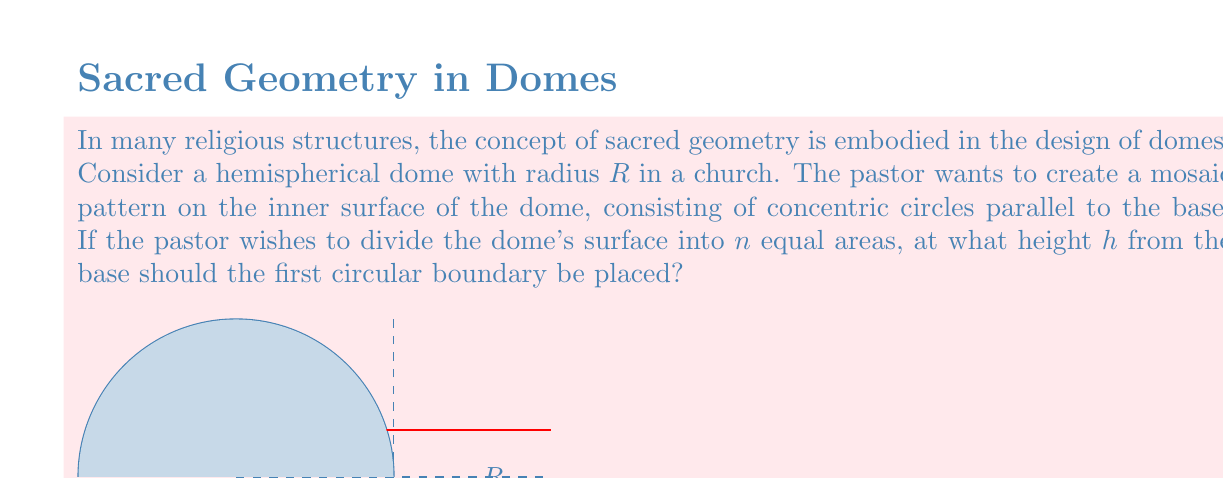Teach me how to tackle this problem. To solve this problem, we'll use concepts from differential geometry and surface area calculations. Let's approach this step-by-step:

1) The surface area of a hemisphere is given by $2\pi R^2$.

2) We want to divide this area into $n$ equal parts. So, the area of each part should be:

   $$A = \frac{2\pi R^2}{n}$$

3) The area of a spherical cap (the portion we're considering) is given by:

   $$A_{cap} = 2\pi R h$$

   where $h$ is the height of the cap from the base of the hemisphere.

4) Since we want this area to be equal to $\frac{2\pi R^2}{n}$, we can set up the equation:

   $$2\pi R h = \frac{2\pi R^2}{n}$$

5) Simplifying this equation:

   $$Rh = \frac{R^2}{n}$$

6) Dividing both sides by $R$:

   $$h = \frac{R}{n}$$

This gives us the height at which the first circular boundary should be placed to divide the dome's surface into $n$ equal areas.
Answer: $h = \frac{R}{n}$ 